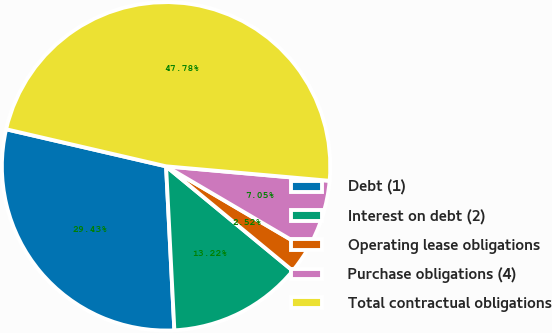Convert chart to OTSL. <chart><loc_0><loc_0><loc_500><loc_500><pie_chart><fcel>Debt (1)<fcel>Interest on debt (2)<fcel>Operating lease obligations<fcel>Purchase obligations (4)<fcel>Total contractual obligations<nl><fcel>29.43%<fcel>13.22%<fcel>2.52%<fcel>7.05%<fcel>47.78%<nl></chart> 